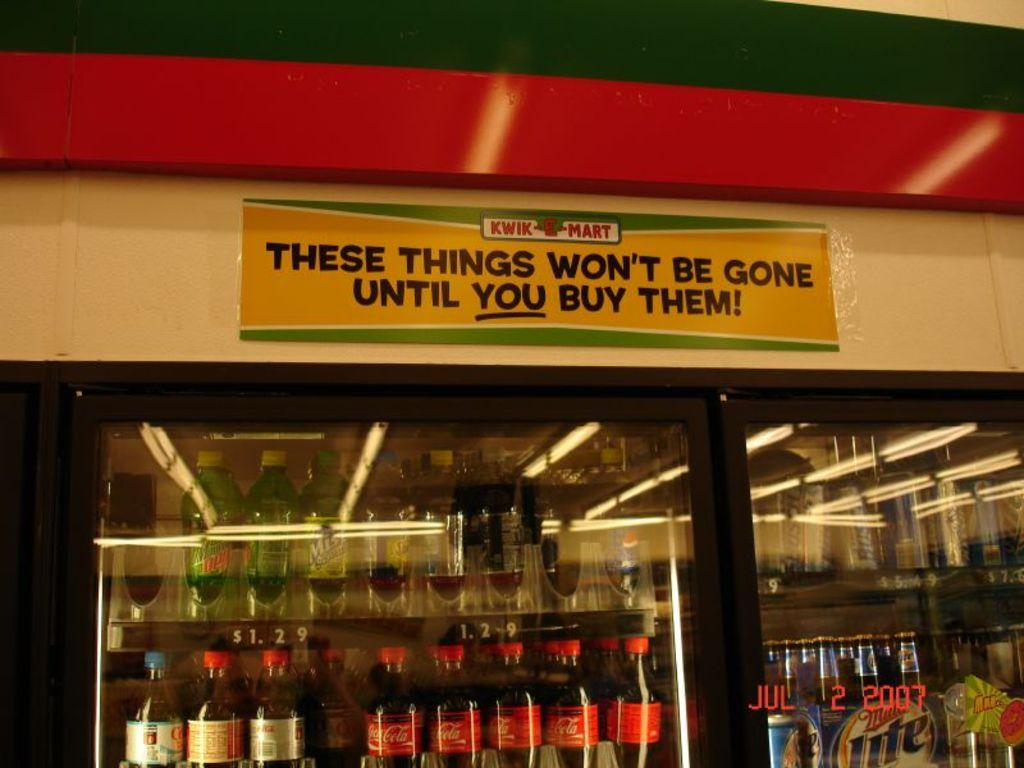What items can be seen inside the fridge in the image? There are bottles in the fridge. What is attached to the fridge in the image? There is a board on the fridge. What position does the chess piece hold on the board in the image? There is no chess piece or board game present in the image. What discovery was made by the person who took the image? The image does not provide any information about a discovery made by the person who took the image. 